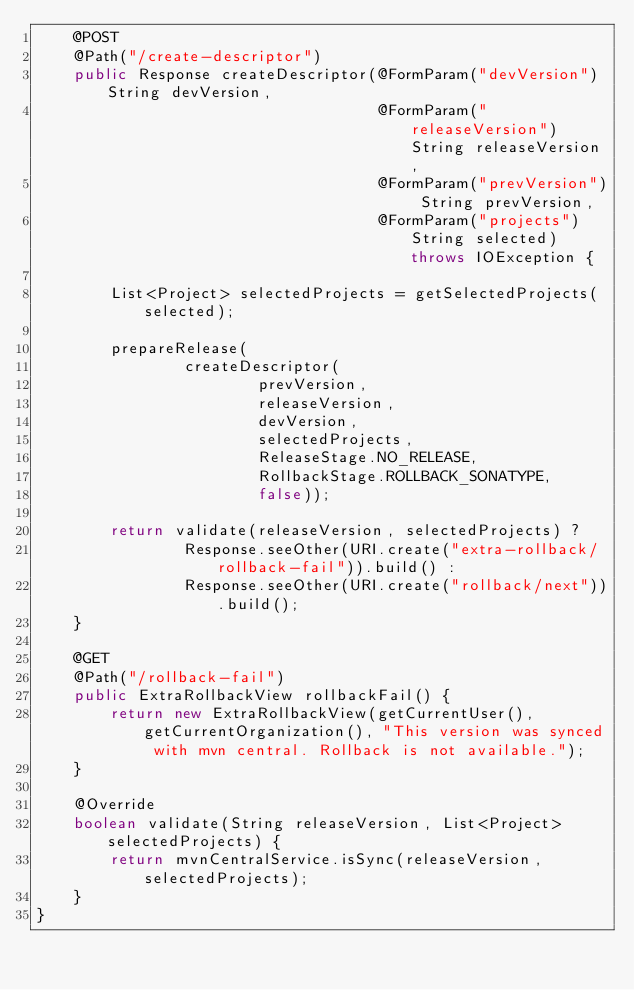<code> <loc_0><loc_0><loc_500><loc_500><_Java_>    @POST
    @Path("/create-descriptor")
    public Response createDescriptor(@FormParam("devVersion") String devVersion,
                                     @FormParam("releaseVersion") String releaseVersion,
                                     @FormParam("prevVersion") String prevVersion,
                                     @FormParam("projects") String selected) throws IOException {

        List<Project> selectedProjects = getSelectedProjects(selected);

        prepareRelease(
                createDescriptor(
                        prevVersion,
                        releaseVersion,
                        devVersion,
                        selectedProjects,
                        ReleaseStage.NO_RELEASE,
                        RollbackStage.ROLLBACK_SONATYPE,
                        false));

        return validate(releaseVersion, selectedProjects) ?
                Response.seeOther(URI.create("extra-rollback/rollback-fail")).build() :
                Response.seeOther(URI.create("rollback/next")).build();
    }

    @GET
    @Path("/rollback-fail")
    public ExtraRollbackView rollbackFail() {
        return new ExtraRollbackView(getCurrentUser(), getCurrentOrganization(), "This version was synced with mvn central. Rollback is not available.");
    }

    @Override
    boolean validate(String releaseVersion, List<Project> selectedProjects) {
        return mvnCentralService.isSync(releaseVersion, selectedProjects);
    }
}
</code> 